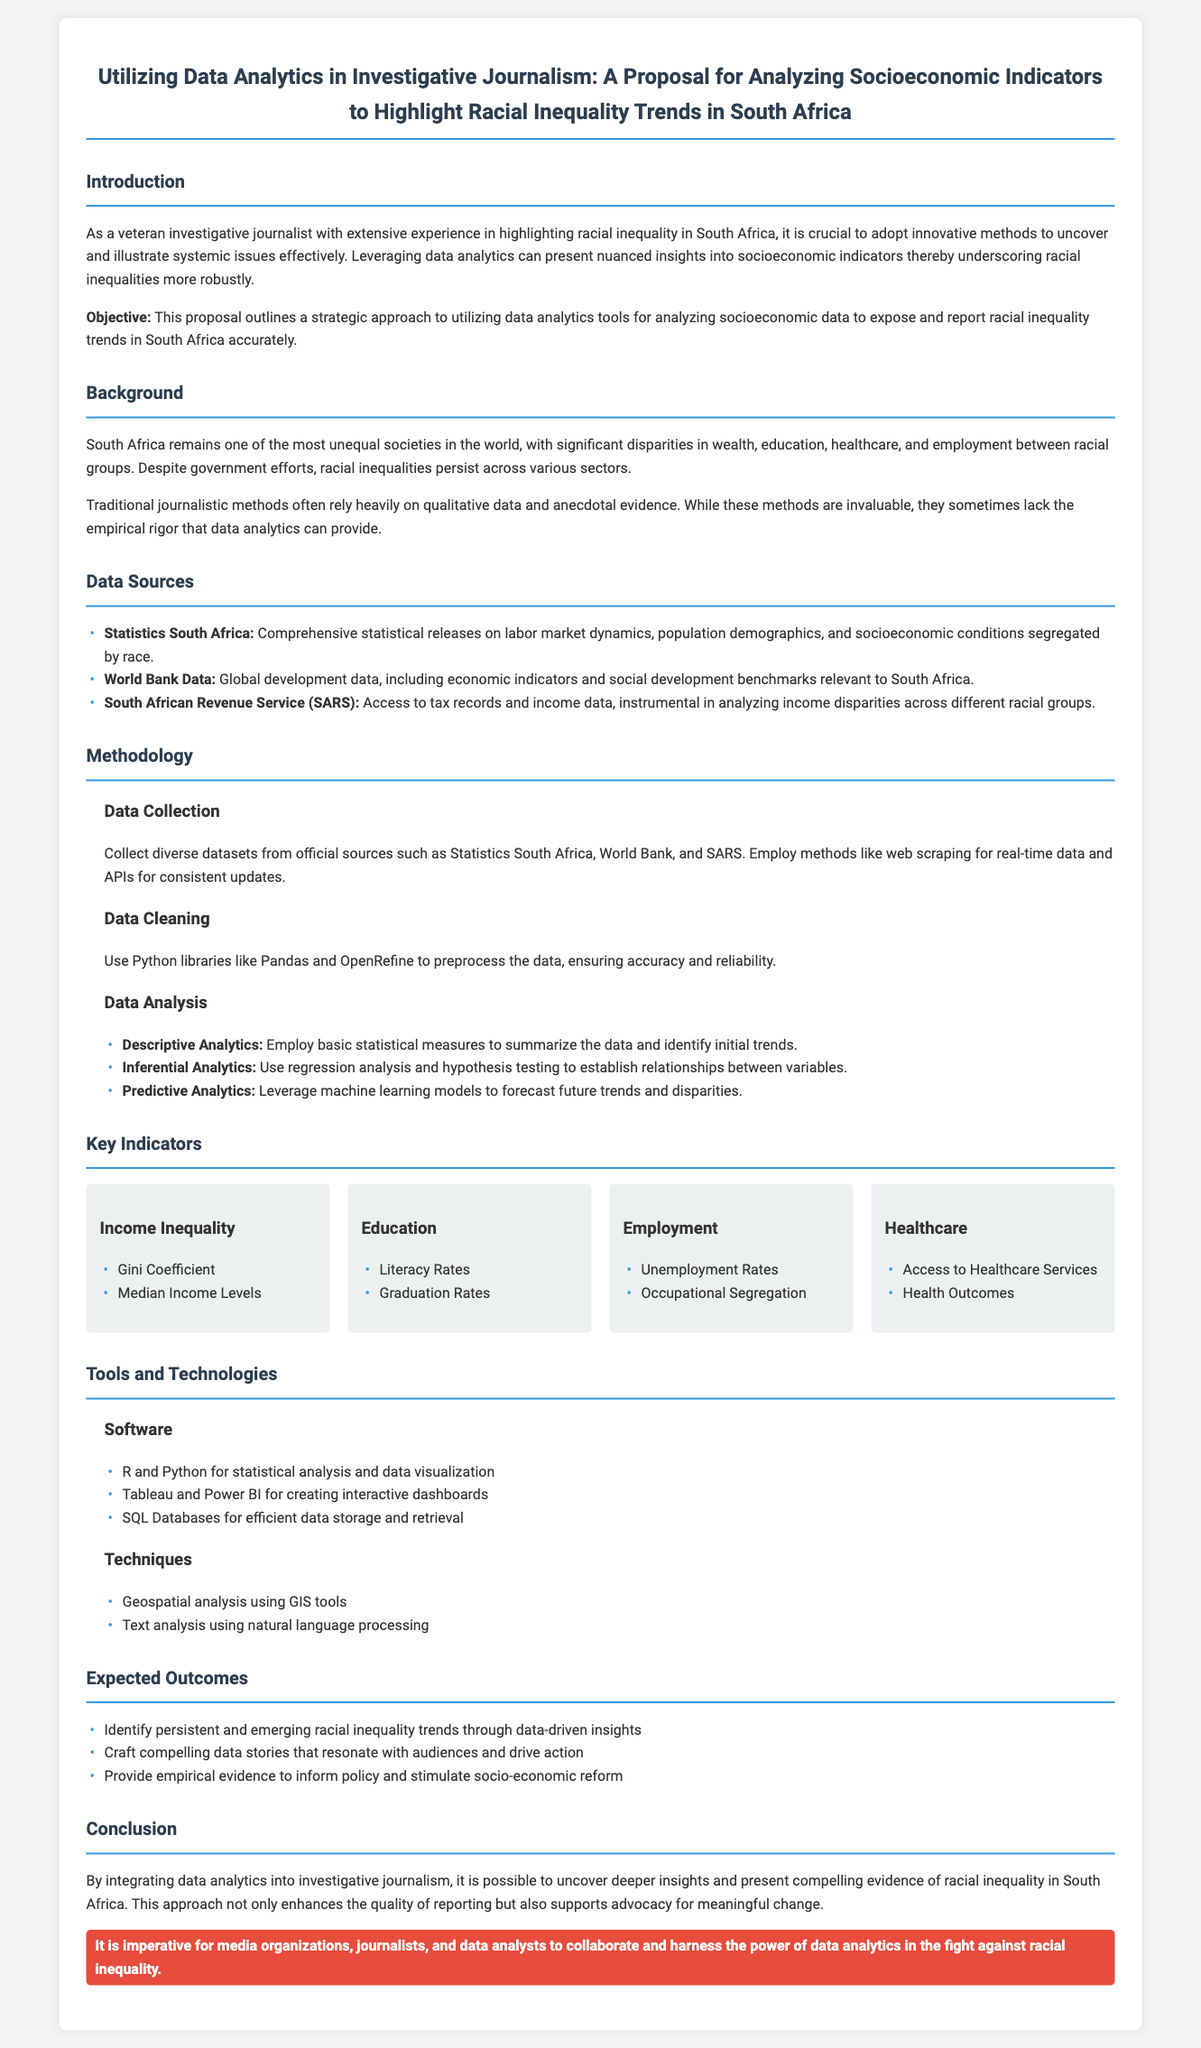what is the main objective of the proposal? The objective is to utilize data analytics tools for analyzing socioeconomic data to expose and report racial inequality trends in South Africa accurately.
Answer: utilize data analytics tools which organization provides comprehensive statistical releases relevant to the proposal? The data source mentioned for comprehensive statistical releases on labor market dynamics is Statistics South Africa.
Answer: Statistics South Africa what are the three methods of data analysis outlined in the proposal? The methods of data analysis outlined are descriptive analytics, inferential analytics, and predictive analytics.
Answer: descriptive analytics, inferential analytics, predictive analytics name one key indicator related to healthcare mentioned in the document. The key indicator related to healthcare mentioned is access to healthcare services.
Answer: access to healthcare services what tools are suggested for statistical analysis and data visualization? The proposal suggests using R and Python for statistical analysis and data visualization.
Answer: R and Python how does the proposal suggest to gather real-time data? The proposal suggests employing methods like web scraping for real-time data collection.
Answer: web scraping what is the expected outcome regarding racial inequality trends? The expected outcome is to identify persistent and emerging racial inequality trends through data-driven insights.
Answer: identify persistent and emerging racial inequality trends who should collaborate according to the conclusion of the proposal? The conclusion emphasizes that media organizations, journalists, and data analysts should collaborate.
Answer: media organizations, journalists, and data analysts 